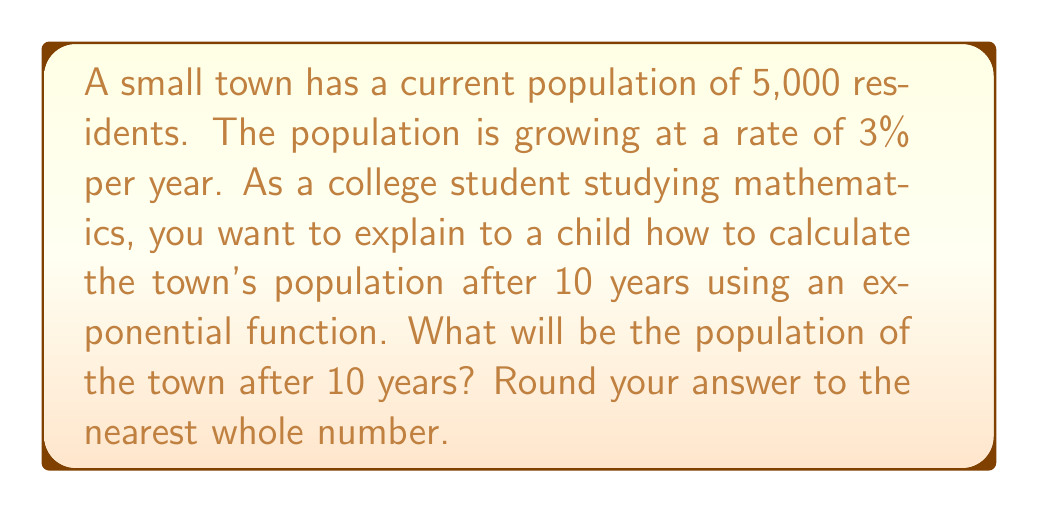Provide a solution to this math problem. Let's break this down step-by-step:

1) The exponential growth formula is:
   $A = P(1 + r)^t$
   Where:
   $A$ = Final amount
   $P$ = Initial amount (principal)
   $r$ = Growth rate (as a decimal)
   $t$ = Time period

2) In this problem:
   $P = 5,000$ (initial population)
   $r = 0.03$ (3% growth rate as a decimal)
   $t = 10$ years

3) Let's plug these values into our formula:
   $A = 5,000(1 + 0.03)^{10}$

4) Simplify inside the parentheses:
   $A = 5,000(1.03)^{10}$

5) Now, we need to calculate $(1.03)^{10}$:
   $(1.03)^{10} \approx 1.3439$

6) Multiply this by the initial population:
   $A = 5,000 \times 1.3439 = 6,719.5$

7) Rounding to the nearest whole number:
   $A \approx 6,720$

Therefore, after 10 years, the population will be approximately 6,720 people.
Answer: 6,720 people 